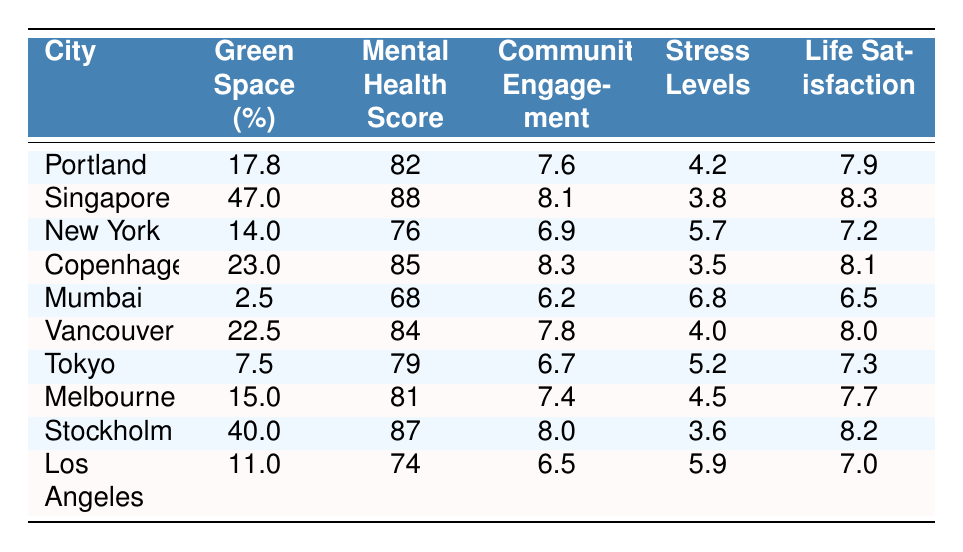What city has the highest green space percentage? Looking at the "Green Space (%)" column, Singapore has the highest value at 47.0%.
Answer: Singapore What is the mental health score for Copenhagen? Referring to the "Mental Health Score" column in the row for Copenhagen, the score is 85.
Answer: 85 Which city has the lowest stress levels? By examining the "Stress Levels" column, Singapore has the lowest stress level of 3.8.
Answer: Singapore What is the difference in life satisfaction scores between Portland and Mumbai? The life satisfaction score for Portland is 7.9 and for Mumbai is 6.5. Therefore, the difference is 7.9 - 6.5 = 1.4.
Answer: 1.4 Is there a positive correlation between green space percentage and mental health score? Both the green space percentages and mental health scores seem to rise together as we increase the percentage; for example, Singapore (47.0%, 88), Stockholm (40.0%, 87), and Copenhagen (23.0%, 85) support this observation.
Answer: Yes What is the average community engagement index for the cities listed? The indices are 7.6, 8.1, 6.9, 8.3, 6.2, 7.8, 6.7, 7.4, 8.0, 6.5. Adding these together gives 78.5, then dividing by 10 results in an average of 7.85.
Answer: 7.85 Which city has the highest mental health score and what is that score? The highest mental health score is 88, which is held by Singapore.
Answer: Singapore, 88 How many cities have a green space percentage greater than 20%? The cities with more than 20% green space are Singapore, Copenhagen, Vancouver, and Stockholm, totaling 4 cities.
Answer: 4 What is the relationship between green space percentage and stress levels in Los Angeles? Los Angeles has 11.0% green space and a stress level of 5.9. Lower green space percentages do not strongly correlate with lower stress, indicating a more complex relationship.
Answer: Complex relationship Which city has the same community engagement index as Tokyo? The community engagement index for Tokyo is 6.7. The city with the same index is New York, which also scores 6.9, hence Tokyo has no exact match but is close to New York.
Answer: No exact match, New York is close 